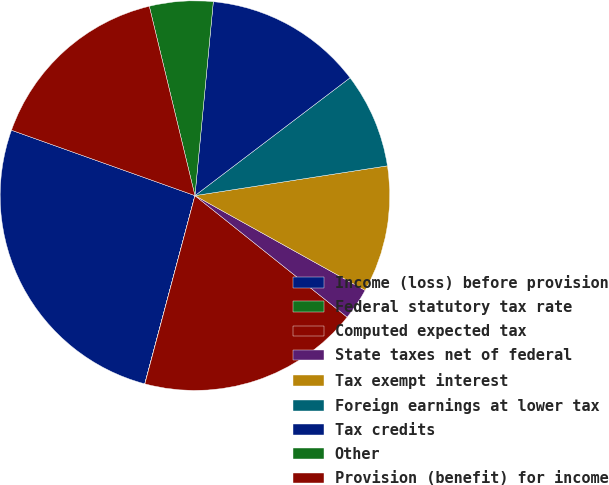Convert chart. <chart><loc_0><loc_0><loc_500><loc_500><pie_chart><fcel>Income (loss) before provision<fcel>Federal statutory tax rate<fcel>Computed expected tax<fcel>State taxes net of federal<fcel>Tax exempt interest<fcel>Foreign earnings at lower tax<fcel>Tax credits<fcel>Other<fcel>Provision (benefit) for income<nl><fcel>26.31%<fcel>0.01%<fcel>18.42%<fcel>2.64%<fcel>10.53%<fcel>7.9%<fcel>13.16%<fcel>5.27%<fcel>15.79%<nl></chart> 